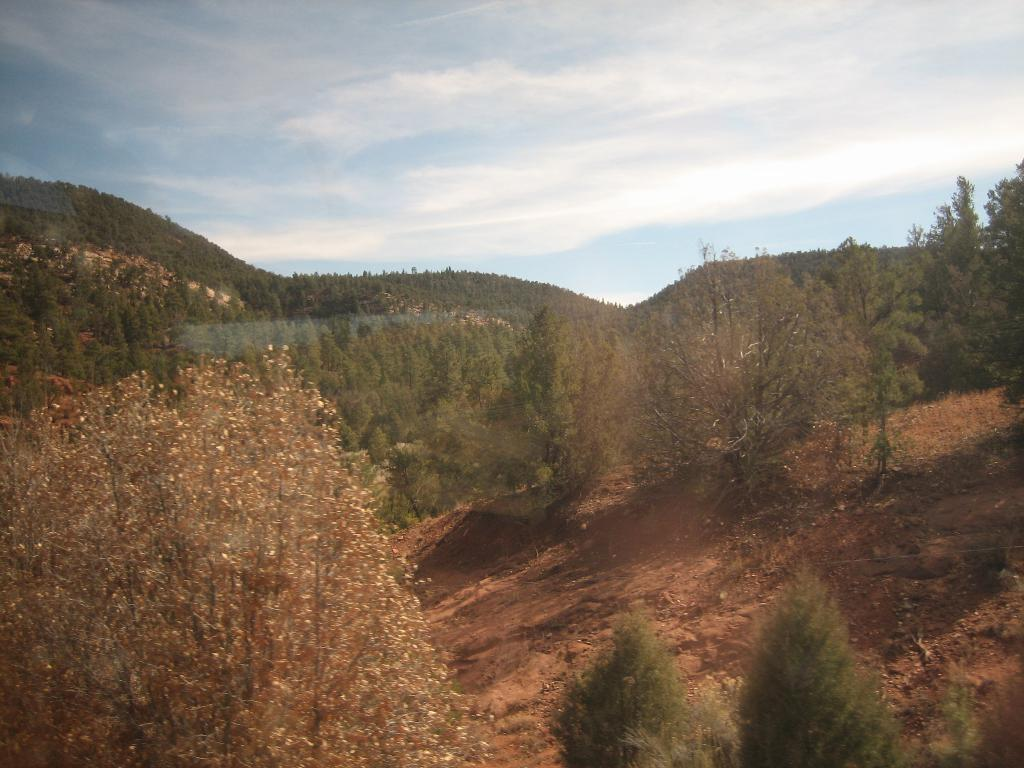What type of natural formation can be seen in the image? There are mountains in the image. What vegetation is present on the mountains? Trees are present on the mountains. What is visible at the top of the image? The sky is visible at the top of the image. How many books are stacked on the mountain in the image? There are no books present in the image; it features mountains with trees. What is the zinc content of the trees on the mountain in the image? There is no information about the zinc content of the trees in the image, as it focuses on the visual appearance of the mountains and trees. 